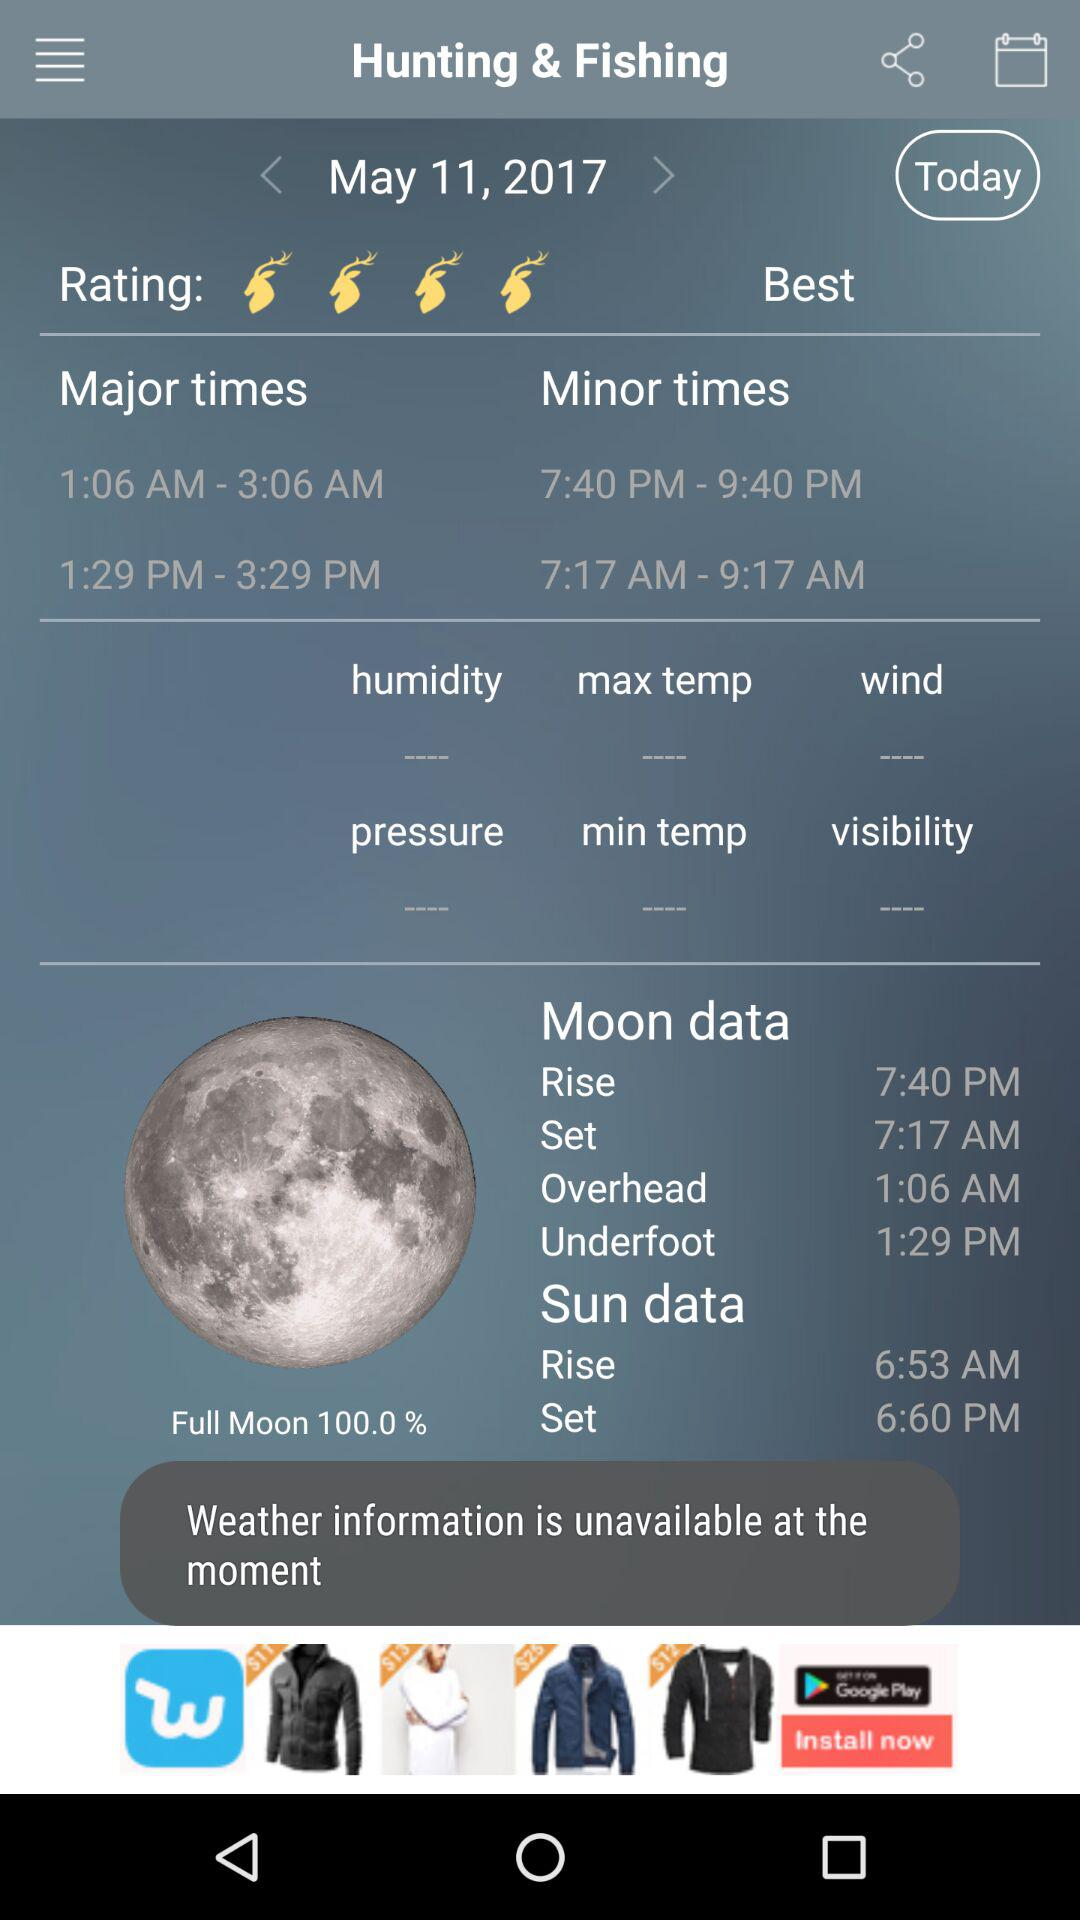What is the major time? The major times are 1:06 AM to 3:06 AM and 1:29 PM to 3:29 PM. 